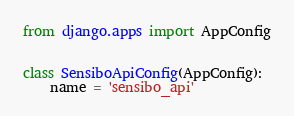Convert code to text. <code><loc_0><loc_0><loc_500><loc_500><_Python_>from django.apps import AppConfig


class SensiboApiConfig(AppConfig):
    name = 'sensibo_api'
</code> 